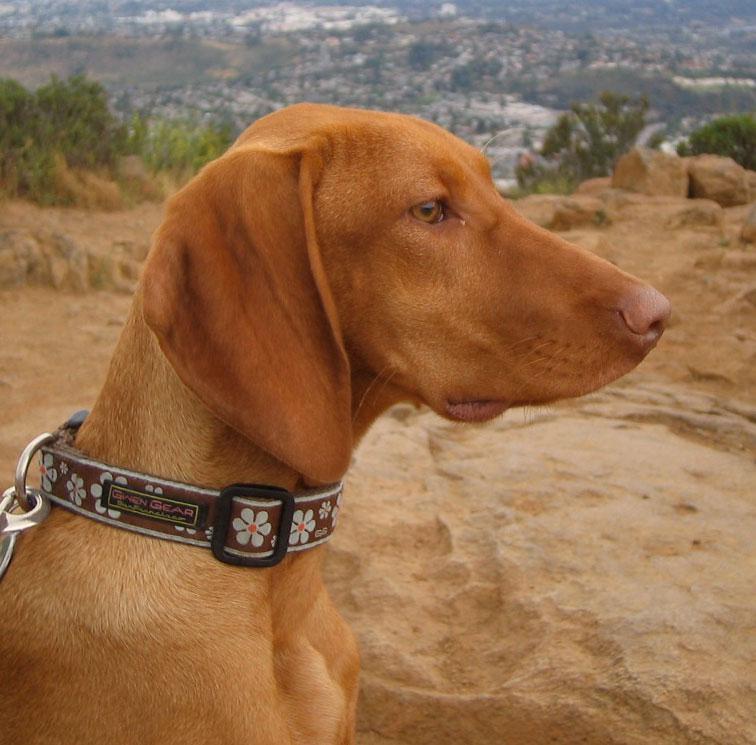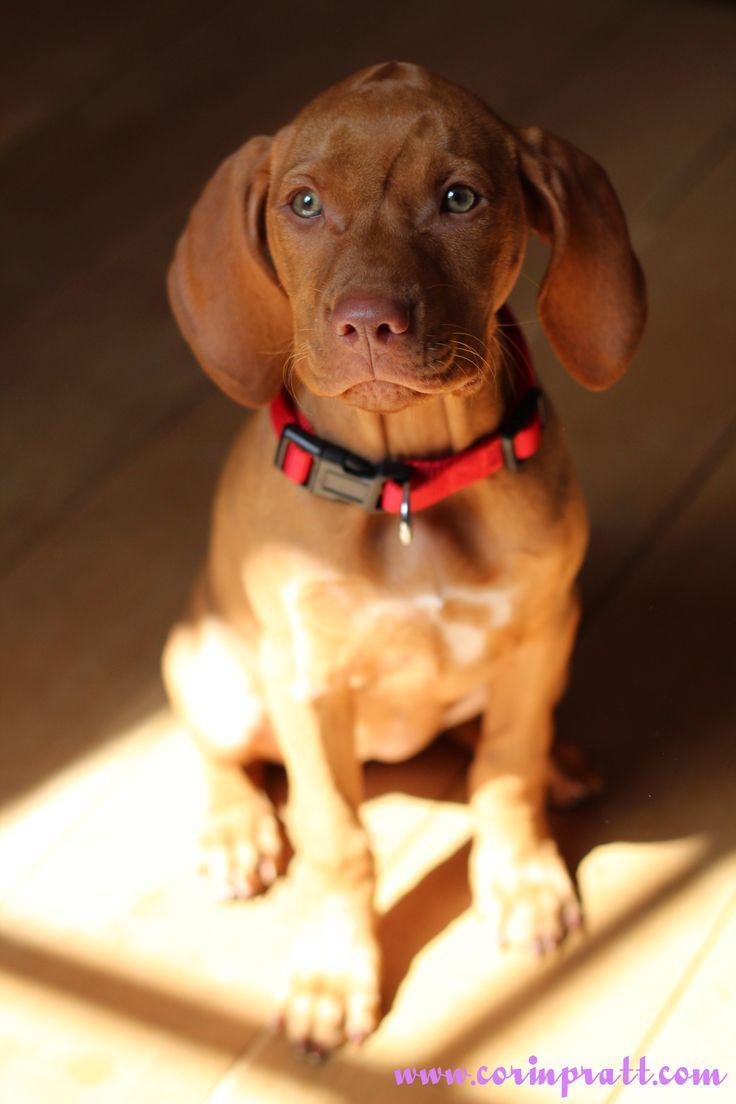The first image is the image on the left, the second image is the image on the right. Considering the images on both sides, is "A dog is wearing a red collar in the right image." valid? Answer yes or no. Yes. The first image is the image on the left, the second image is the image on the right. For the images shown, is this caption "In at least one image there is a light brown puppy with a red and black collar sitting forward." true? Answer yes or no. Yes. 